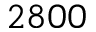<formula> <loc_0><loc_0><loc_500><loc_500>2 8 0 0</formula> 